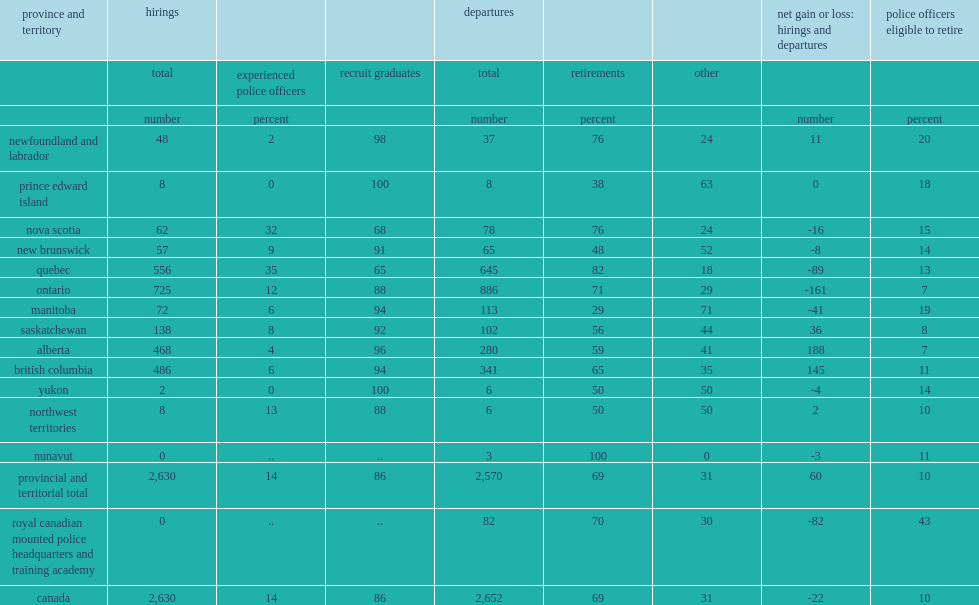How many police officers were hired by police services in canada in 2015/2016? 2630.0. What is the percentage of graduates hired by police services in canada? 86.0. What is the percentage of experienced officers hired by police services in canada?? 14.0. According to police reported,how many officers officers departed their service in 2015/2016? 2652.0. According to police reported,what is the percentage of officers departed their service for retirement in 2015/2016? 69.0. According to police reported,what is the percentage of officers departed their service for other reasons such as a job with another police service, a career change, or other reasons in 2015/2016? 31.0. What is the percentage of officers in canada were eligible to retire but did not in 2015/2016? 10.0. What is the proportion of officers eligible to retire in ontario? 7.0. What is the proportion of officers eligible to retire in prince edward island? 18.0. What is the proportion of officers eligible to retire in manitoba? 19.0. What is the proportion of officers eligible to retire in in newfoundland and labrador? 20.0. 